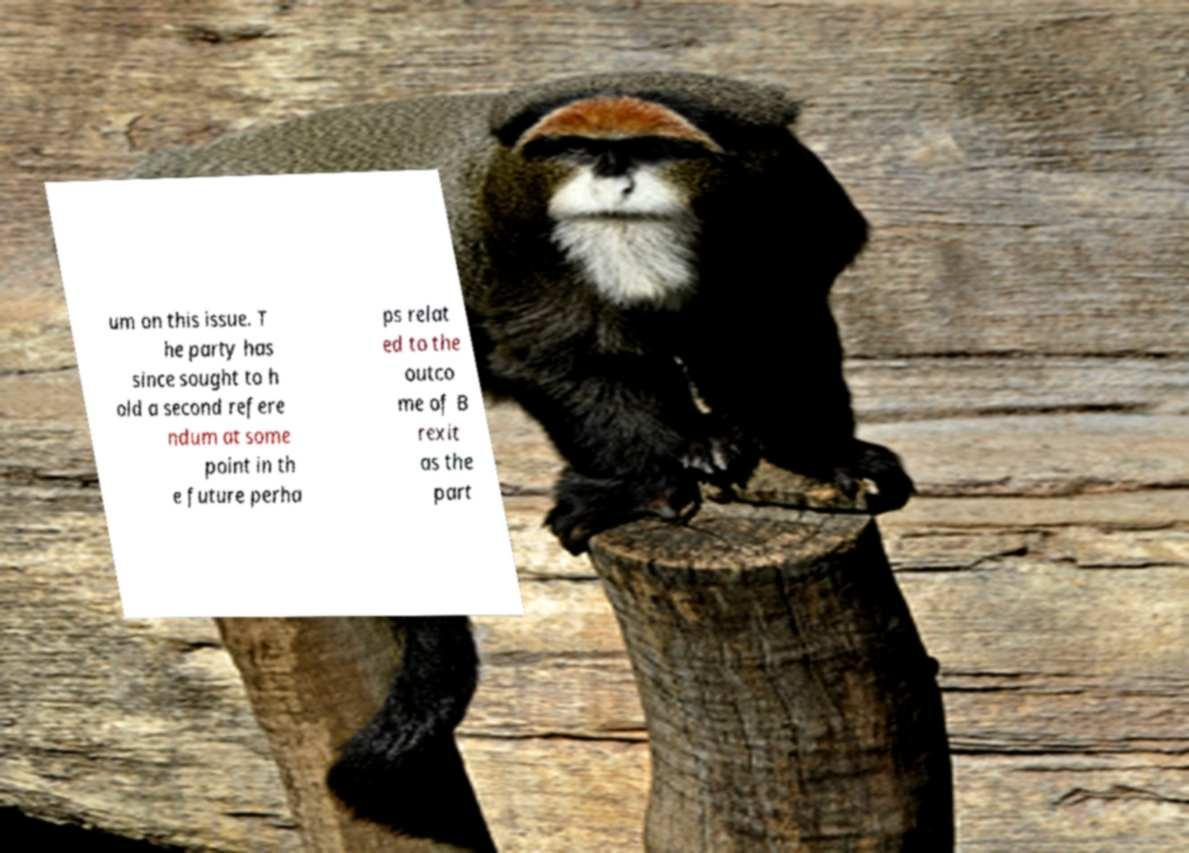Please identify and transcribe the text found in this image. um on this issue. T he party has since sought to h old a second refere ndum at some point in th e future perha ps relat ed to the outco me of B rexit as the part 